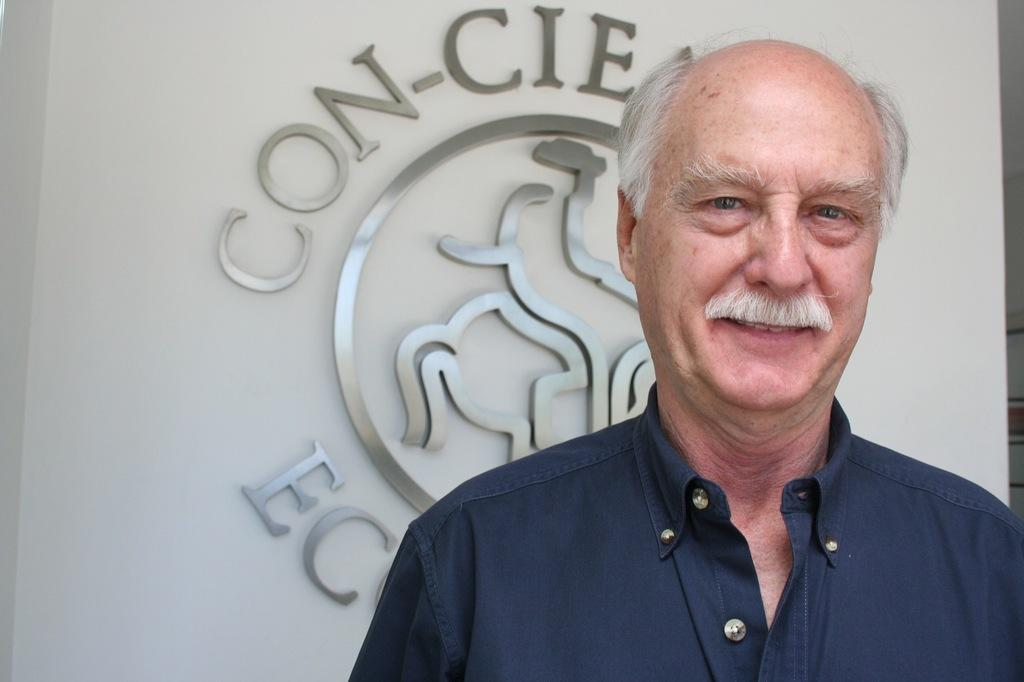What is the main subject of the image? There is a person standing in the image. Where is the person standing in relation to the wall? The person is standing in front of a wall. What can be seen on the wall? There is a logo and some text on the wall. How many dimes are scattered on the ground after the person dropped them in the image? There are no dimes present in the image, and the person is not shown dropping any coins. 